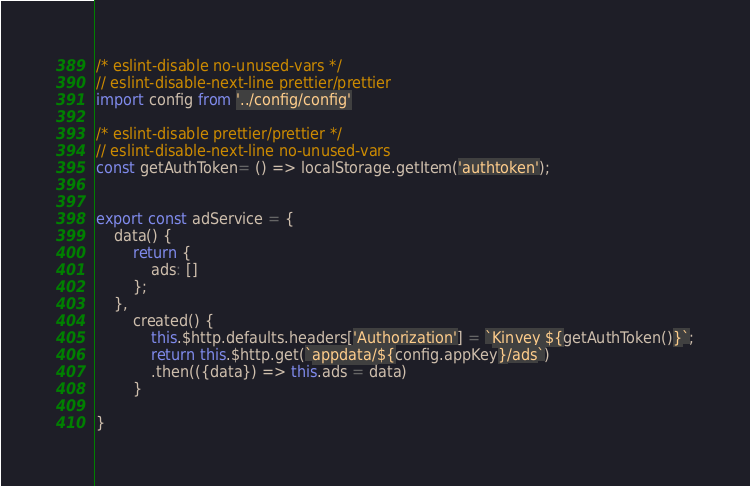<code> <loc_0><loc_0><loc_500><loc_500><_JavaScript_>/* eslint-disable no-unused-vars */
// eslint-disable-next-line prettier/prettier
import config from '../config/config'

/* eslint-disable prettier/prettier */
// eslint-disable-next-line no-unused-vars
const getAuthToken= () => localStorage.getItem('authtoken');


export const adService = {
    data() {
        return {
            ads: []
        };
    },
        created() {
            this.$http.defaults.headers['Authorization'] = `Kinvey ${getAuthToken()}`;
            return this.$http.get(`appdata/${config.appKey}/ads`)
            .then(({data}) => this.ads = data)
        }
    
}</code> 